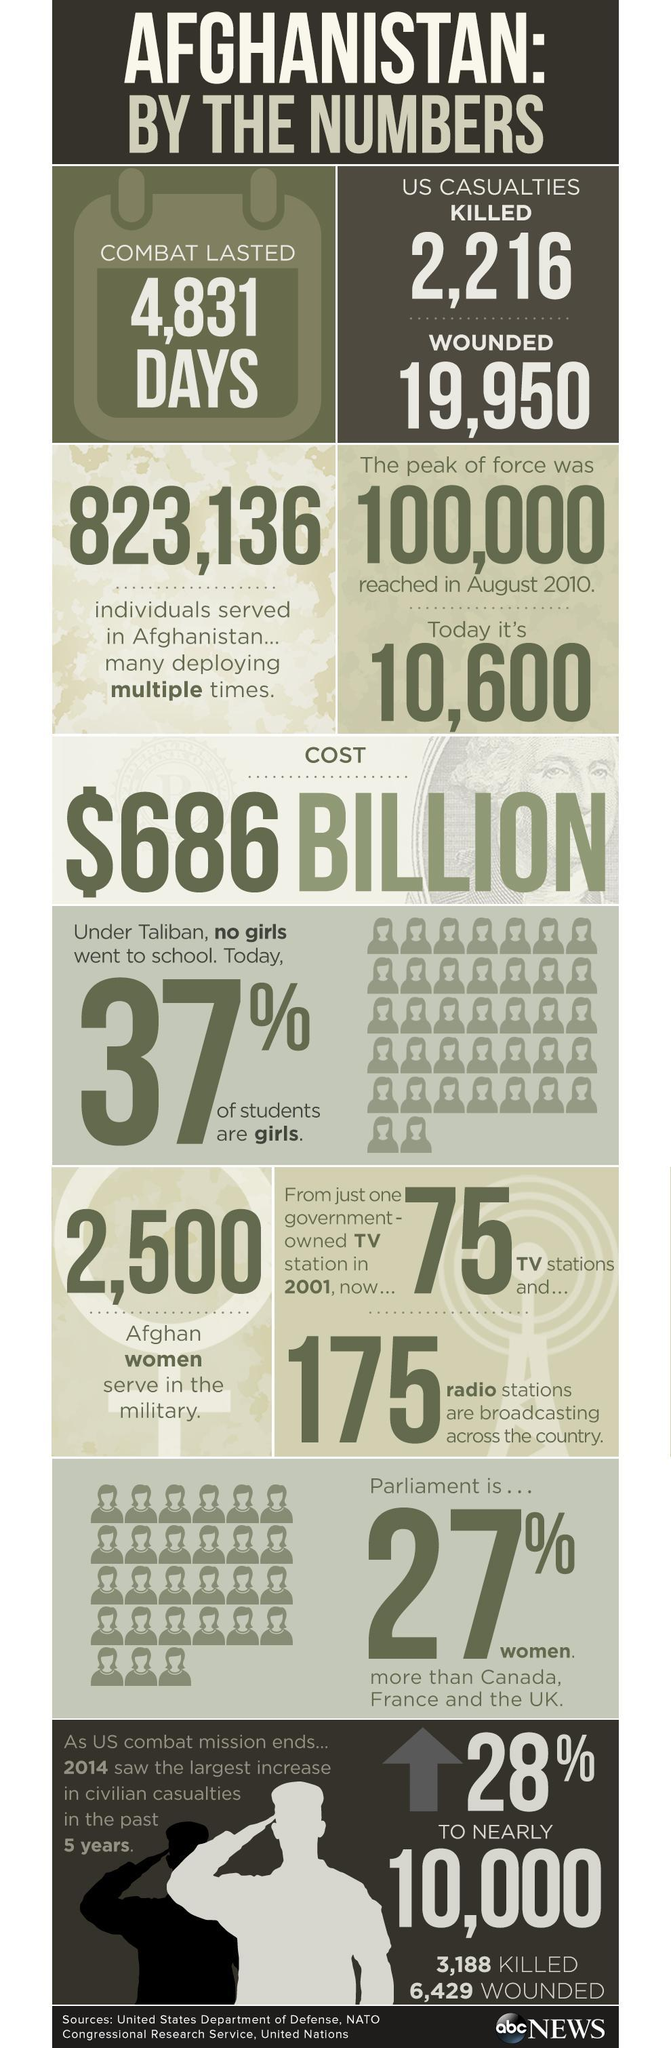How long was the US combat mission in Afghanistan?
Answer the question with a short phrase. 4,831 DAYS How many Afghan women serve in the military? 2,500 How many Americans were killed in the US combat mission in Afghanistan? 2,216 